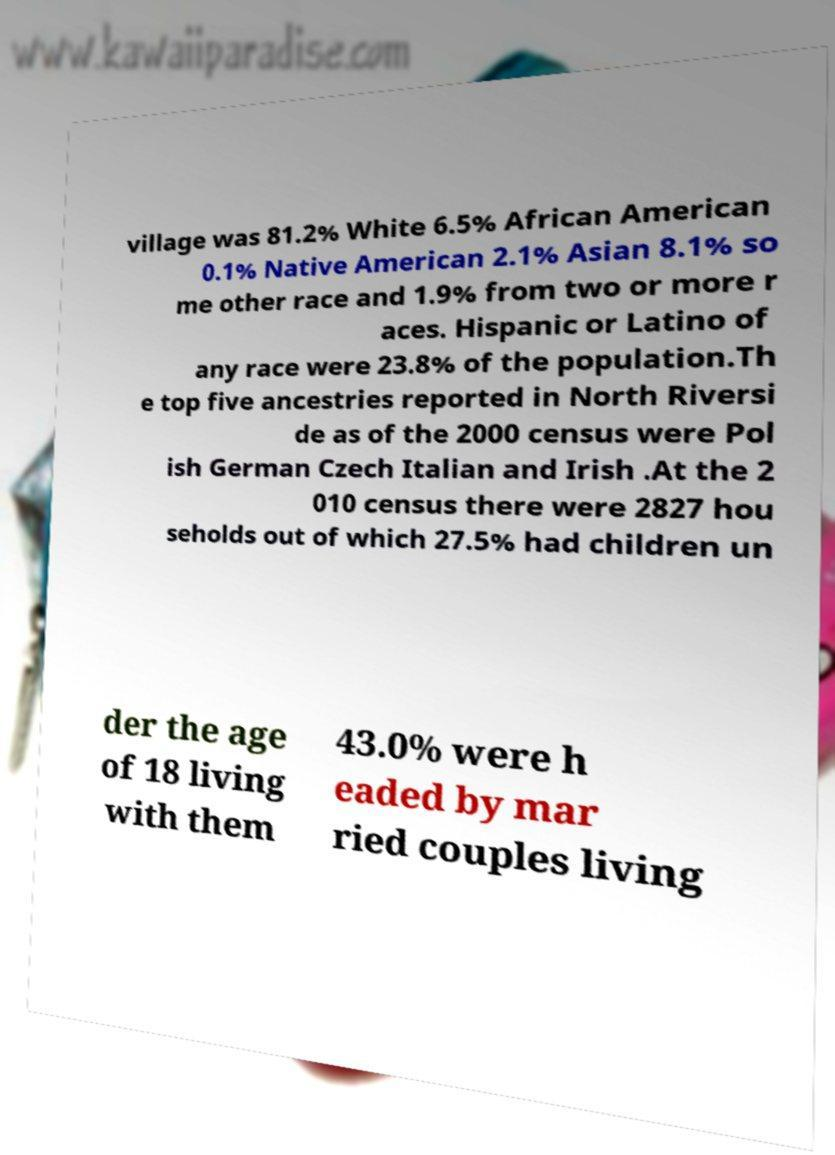For documentation purposes, I need the text within this image transcribed. Could you provide that? village was 81.2% White 6.5% African American 0.1% Native American 2.1% Asian 8.1% so me other race and 1.9% from two or more r aces. Hispanic or Latino of any race were 23.8% of the population.Th e top five ancestries reported in North Riversi de as of the 2000 census were Pol ish German Czech Italian and Irish .At the 2 010 census there were 2827 hou seholds out of which 27.5% had children un der the age of 18 living with them 43.0% were h eaded by mar ried couples living 